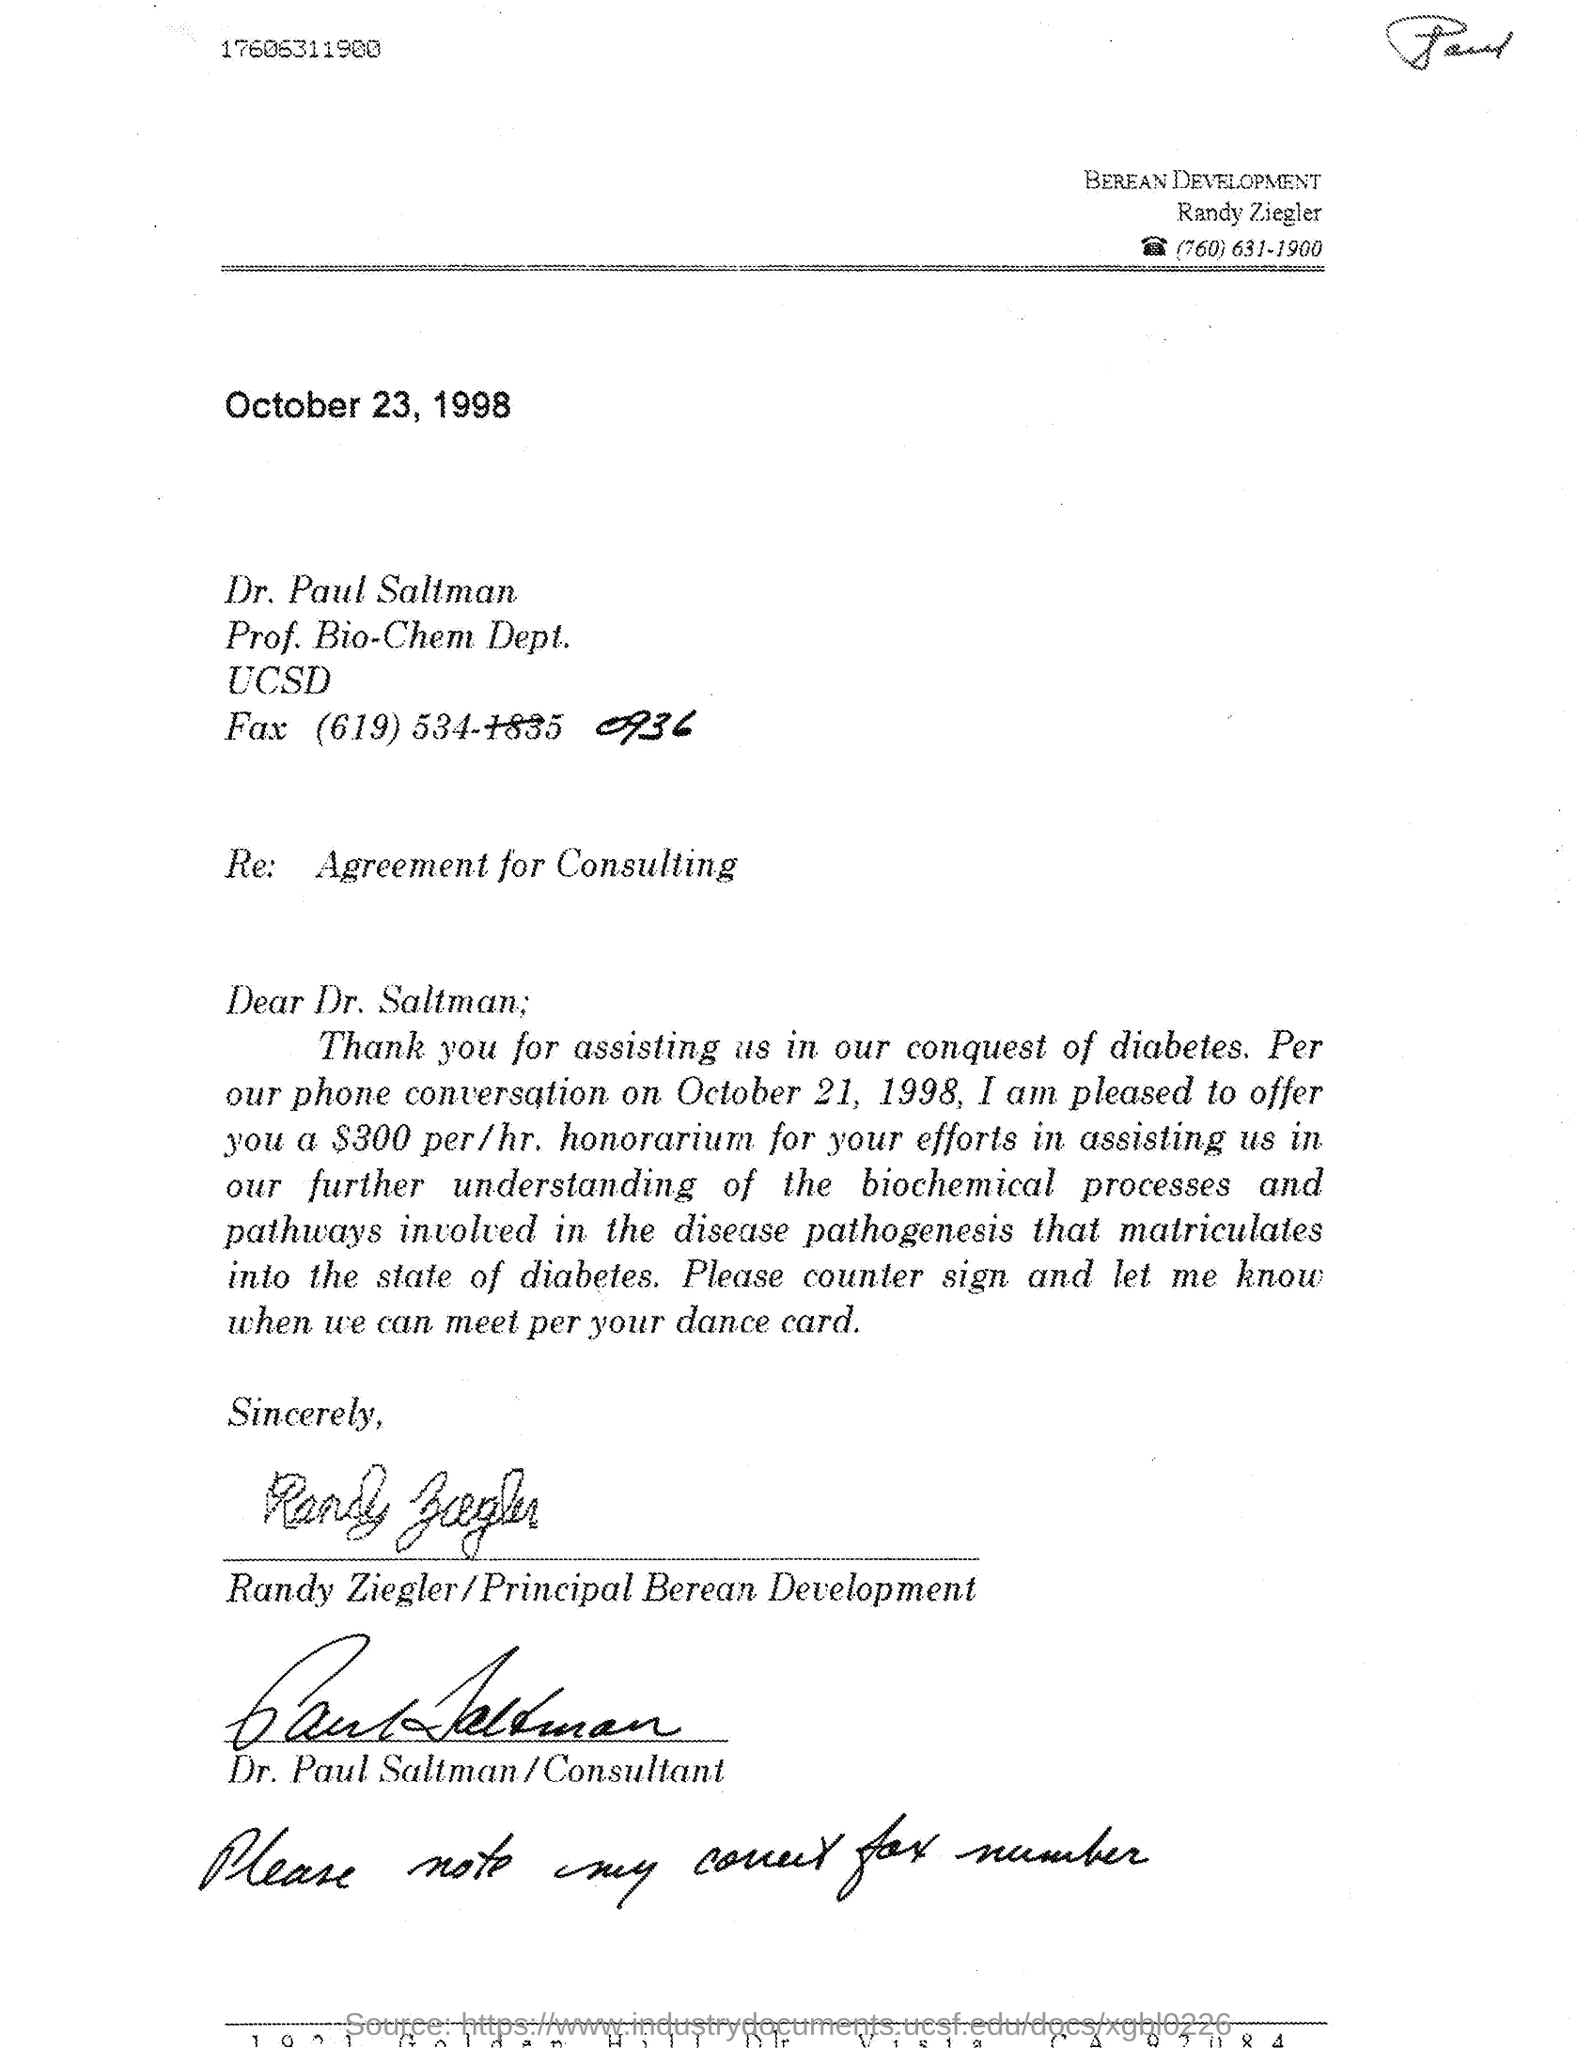Indicate a few pertinent items in this graphic. The letter's issued date is October 23, 1998. Randy Ziegler is the Principal Berean Development Company. The fax number of Dr. Paul Saltman is (619) 534-0936. The phone number of Randy Ziegler mentioned in the letterhead is (760) 631-1900. 